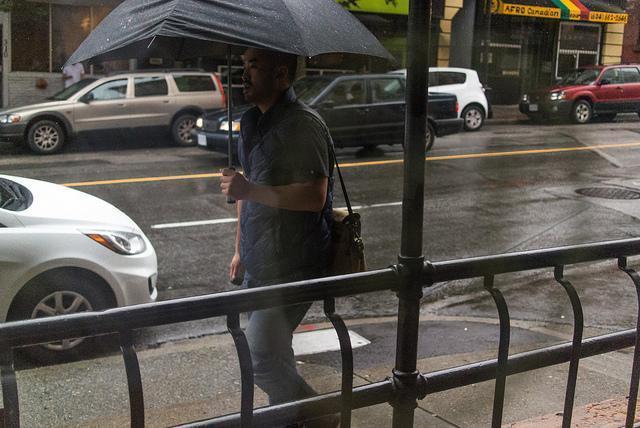How many people in the image?
Give a very brief answer. 1. How many buses are there?
Give a very brief answer. 0. How many cars are there?
Give a very brief answer. 5. 